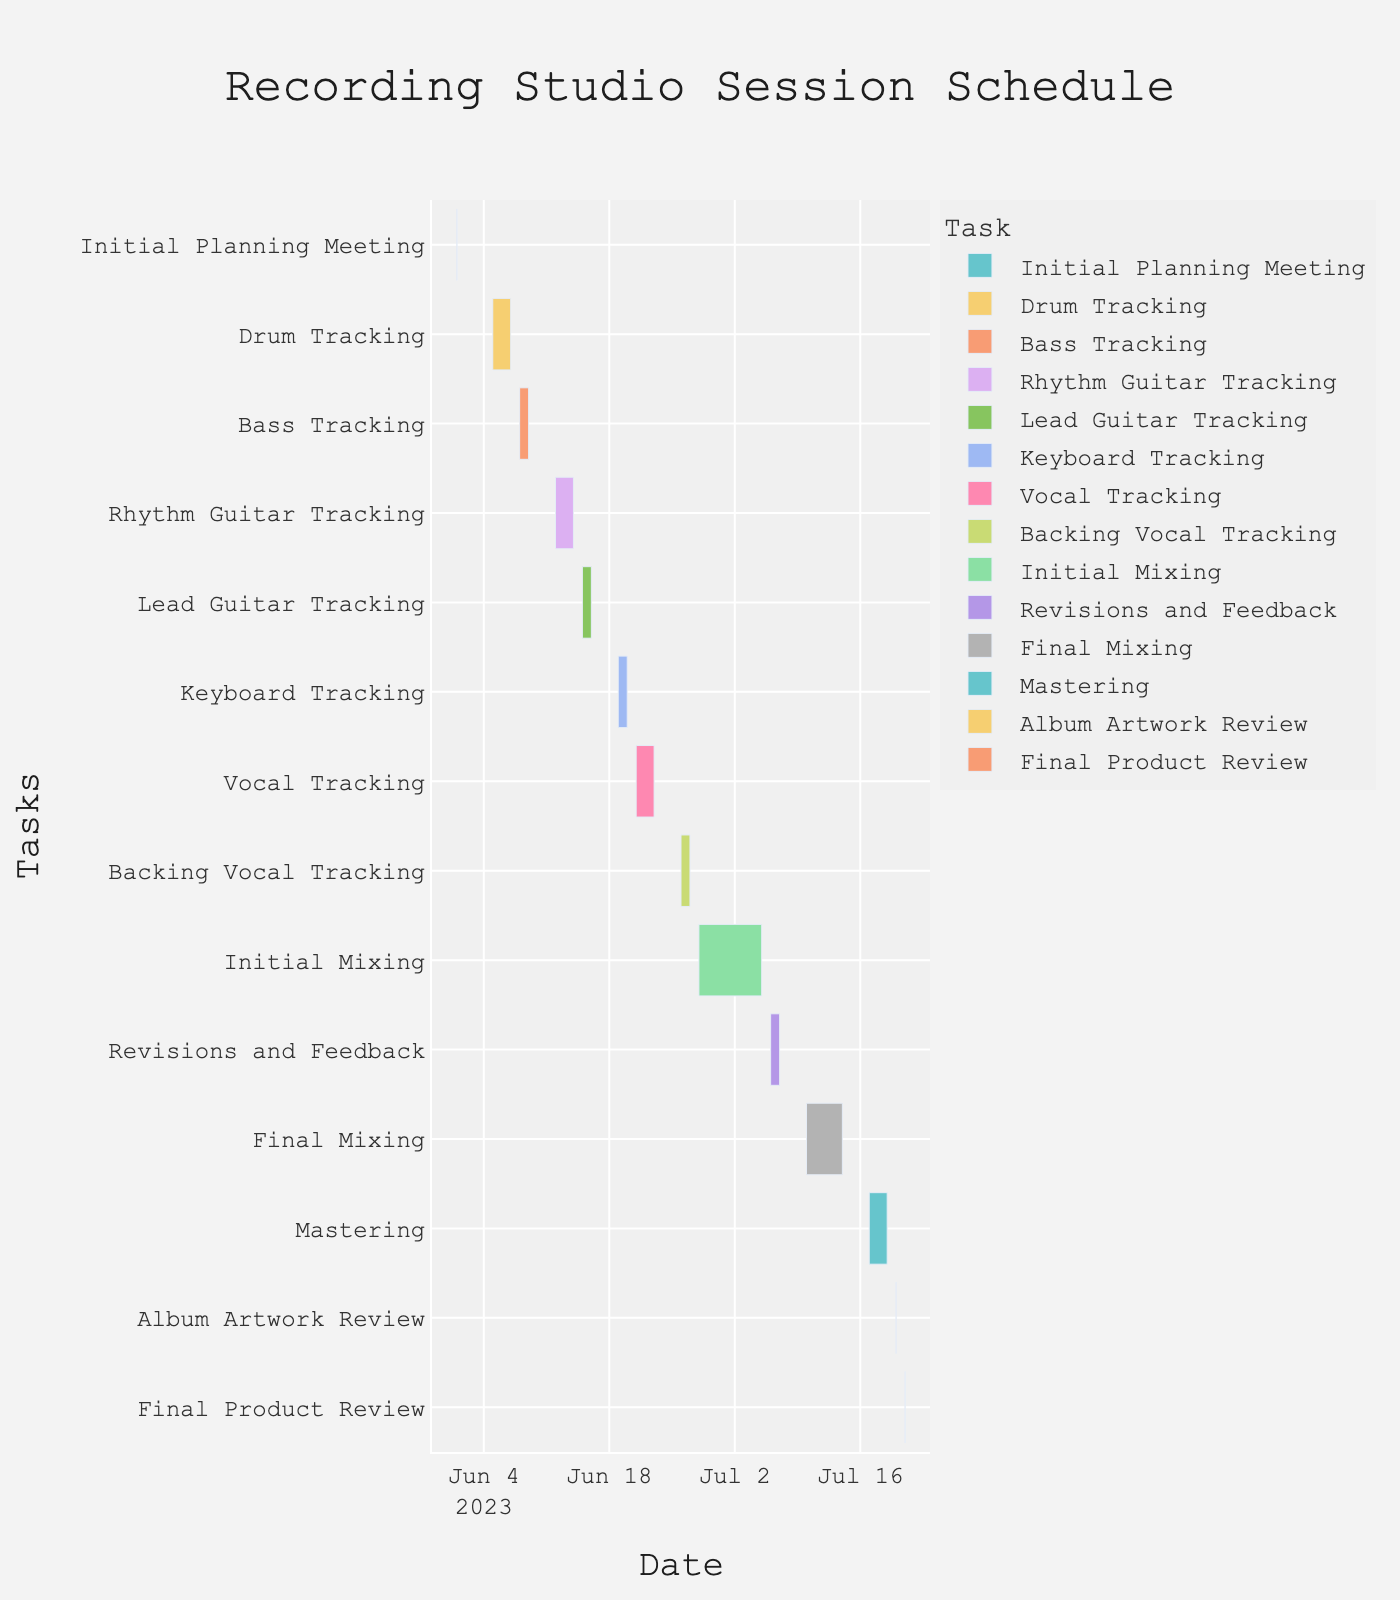When does the Initial Planning Meeting take place? The figure shows a Gantt chart with the tasks listed on the y-axis and the timeline on the x-axis. The "Initial Planning Meeting" is at the top of the chart, marked on June 1, 2023.
Answer: June 1, 2023 How many days are dedicated to Drum Tracking? By hovering or closely observing the "Drum Tracking" bar in the chart, it spans from June 5 to June 7, 2023, which is 3 days in total.
Answer: 3 days Which task starts immediately after the Rhythm Guitar Tracking? The "Rhythm Guitar Tracking" task ends on June 14, 2023. Observing the following task on the Gantt chart, "Lead Guitar Tracking" starts on June 15, 2023, immediately after Rhythm Guitar Tracking.
Answer: Lead Guitar Tracking How many tasks are in the mixing phase? The mixing phase involves multiple steps: "Initial Mixing," "Revisions and Feedback," and "Final Mixing." By counting these tasks on the chart, we see there are three tasks in the mixing phase.
Answer: 3 tasks What is the duration of the entire album recording schedule from the start to the final product review? The recording schedule starts with the "Initial Planning Meeting" on June 1, 2023, and ends with the "Final Product Review" on July 21, 2023. Counting all days inclusively, we get a duration of 51 days.
Answer: 51 days Which tracking task is the shortest in duration? By comparing the duration of all tracking tasks in the chart, "Bass Tracking," which spans from June 8 to June 9, 2023, is the shortest, lasting 2 days.
Answer: Bass Tracking On what date does the Vocal Tracking start and how long does it last? The "Vocal Tracking" task starts on June 21, 2023, and ends on June 23, 2023. It lasts for 3 days.
Answer: June 21, 2023, lasts 3 days How long is the gap between Initial Mixing and Revisions and Feedback? The "Initial Mixing" ends on July 5, 2023, and "Revisions and Feedback" starts on July 6, 2023. There is no gap between these tasks; they are consecutive.
Answer: No gap What is the total duration of all mixing-related tasks? The "Initial Mixing" (June 28 - July 5), "Revisions and Feedback" (July 6 - July 7), and "Final Mixing" (July 10 - July 14) tasks last. Summing up: Initial Mixing (8 days), Revisions and Feedback (2 days), Final Mixing (5 days), total is 15 days.
Answer: 15 days 